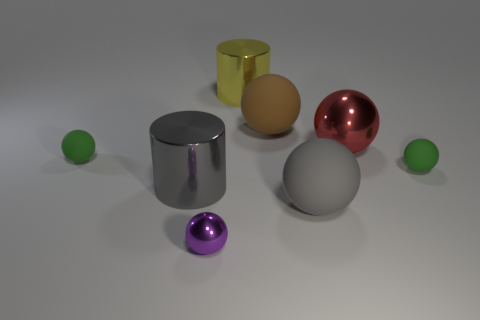What number of other objects are the same shape as the brown rubber object?
Offer a very short reply. 5. Are there fewer large metallic cylinders that are behind the large yellow thing than balls that are in front of the large gray metal thing?
Keep it short and to the point. Yes. Are the yellow cylinder and the cylinder that is in front of the big red shiny sphere made of the same material?
Ensure brevity in your answer.  Yes. Are there more metal balls than large yellow metal cylinders?
Offer a very short reply. Yes. What shape is the small green rubber object that is behind the green ball that is in front of the matte ball left of the gray metallic thing?
Keep it short and to the point. Sphere. Do the big gray object to the left of the large gray rubber sphere and the yellow cylinder that is to the left of the big red thing have the same material?
Your response must be concise. Yes. There is a gray object that is the same material as the red sphere; what shape is it?
Keep it short and to the point. Cylinder. How many big shiny objects are there?
Your response must be concise. 3. The green thing that is on the right side of the gray thing that is left of the brown rubber ball is made of what material?
Ensure brevity in your answer.  Rubber. What color is the big shiny cylinder that is behind the tiny object right of the rubber thing in front of the gray shiny object?
Your answer should be compact. Yellow. 